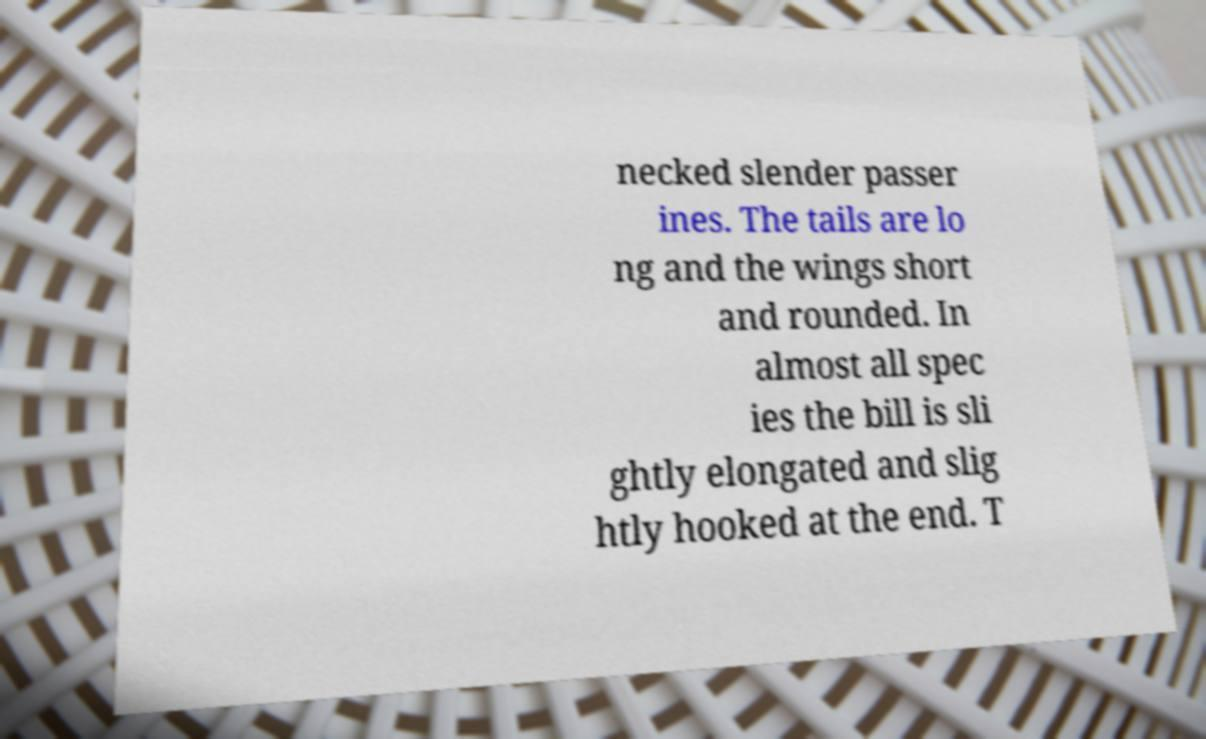Could you assist in decoding the text presented in this image and type it out clearly? necked slender passer ines. The tails are lo ng and the wings short and rounded. In almost all spec ies the bill is sli ghtly elongated and slig htly hooked at the end. T 